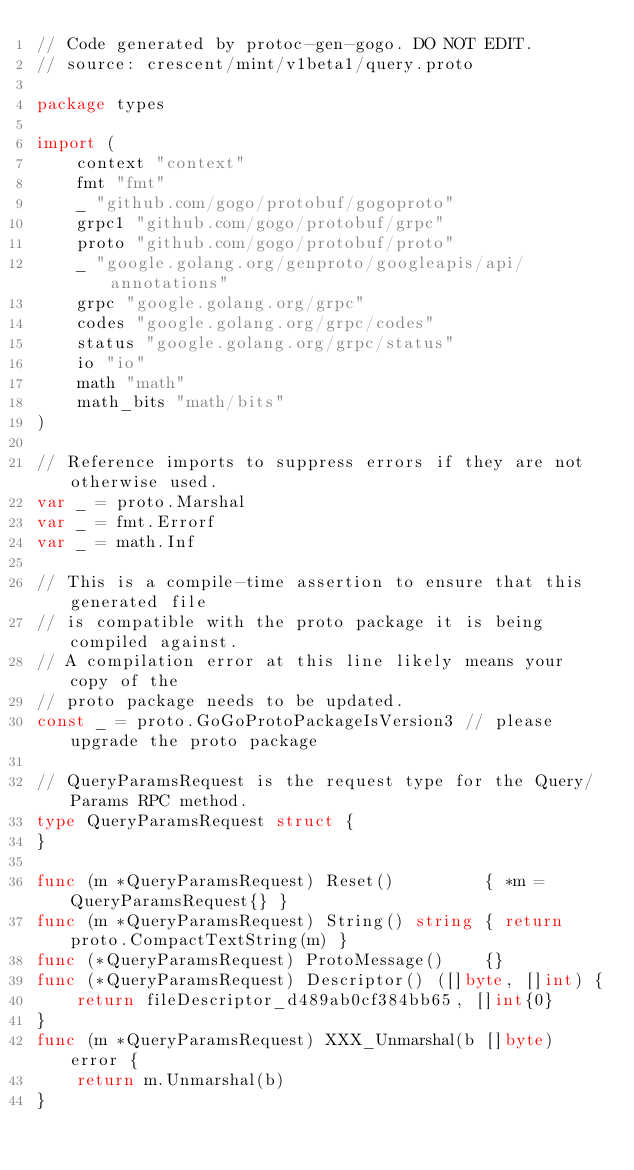Convert code to text. <code><loc_0><loc_0><loc_500><loc_500><_Go_>// Code generated by protoc-gen-gogo. DO NOT EDIT.
// source: crescent/mint/v1beta1/query.proto

package types

import (
	context "context"
	fmt "fmt"
	_ "github.com/gogo/protobuf/gogoproto"
	grpc1 "github.com/gogo/protobuf/grpc"
	proto "github.com/gogo/protobuf/proto"
	_ "google.golang.org/genproto/googleapis/api/annotations"
	grpc "google.golang.org/grpc"
	codes "google.golang.org/grpc/codes"
	status "google.golang.org/grpc/status"
	io "io"
	math "math"
	math_bits "math/bits"
)

// Reference imports to suppress errors if they are not otherwise used.
var _ = proto.Marshal
var _ = fmt.Errorf
var _ = math.Inf

// This is a compile-time assertion to ensure that this generated file
// is compatible with the proto package it is being compiled against.
// A compilation error at this line likely means your copy of the
// proto package needs to be updated.
const _ = proto.GoGoProtoPackageIsVersion3 // please upgrade the proto package

// QueryParamsRequest is the request type for the Query/Params RPC method.
type QueryParamsRequest struct {
}

func (m *QueryParamsRequest) Reset()         { *m = QueryParamsRequest{} }
func (m *QueryParamsRequest) String() string { return proto.CompactTextString(m) }
func (*QueryParamsRequest) ProtoMessage()    {}
func (*QueryParamsRequest) Descriptor() ([]byte, []int) {
	return fileDescriptor_d489ab0cf384bb65, []int{0}
}
func (m *QueryParamsRequest) XXX_Unmarshal(b []byte) error {
	return m.Unmarshal(b)
}</code> 